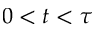<formula> <loc_0><loc_0><loc_500><loc_500>0 < t < \tau</formula> 